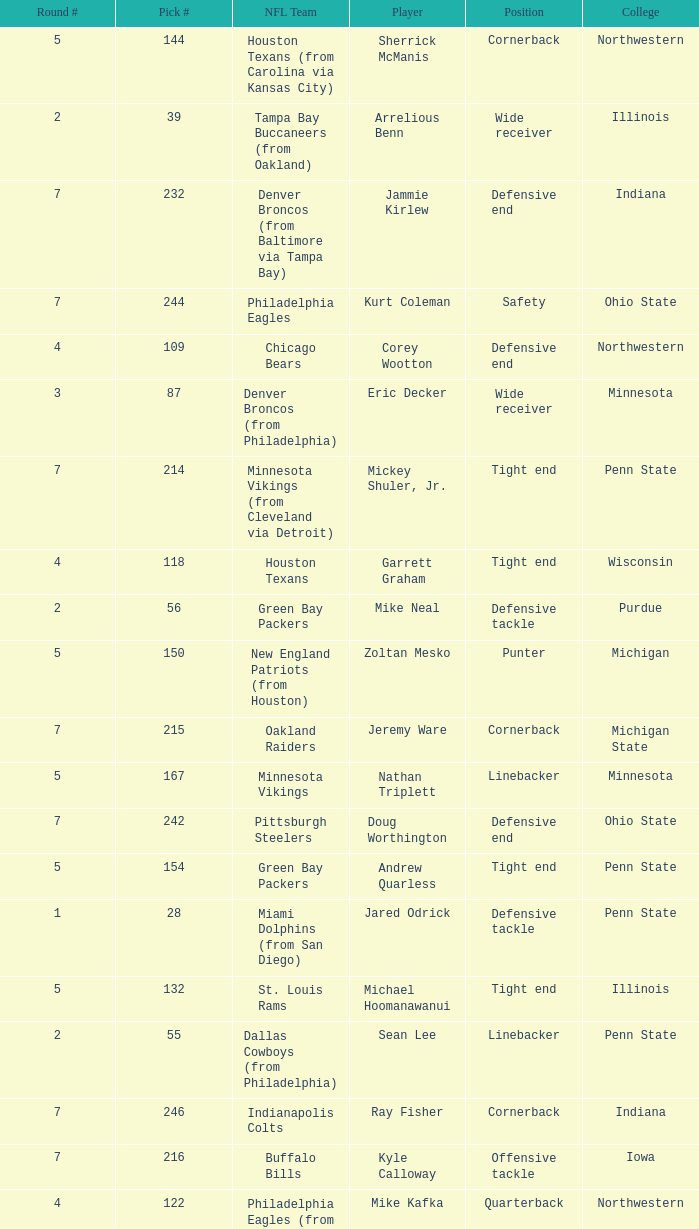How many NFL teams does Stevie Brown play for? 1.0. 